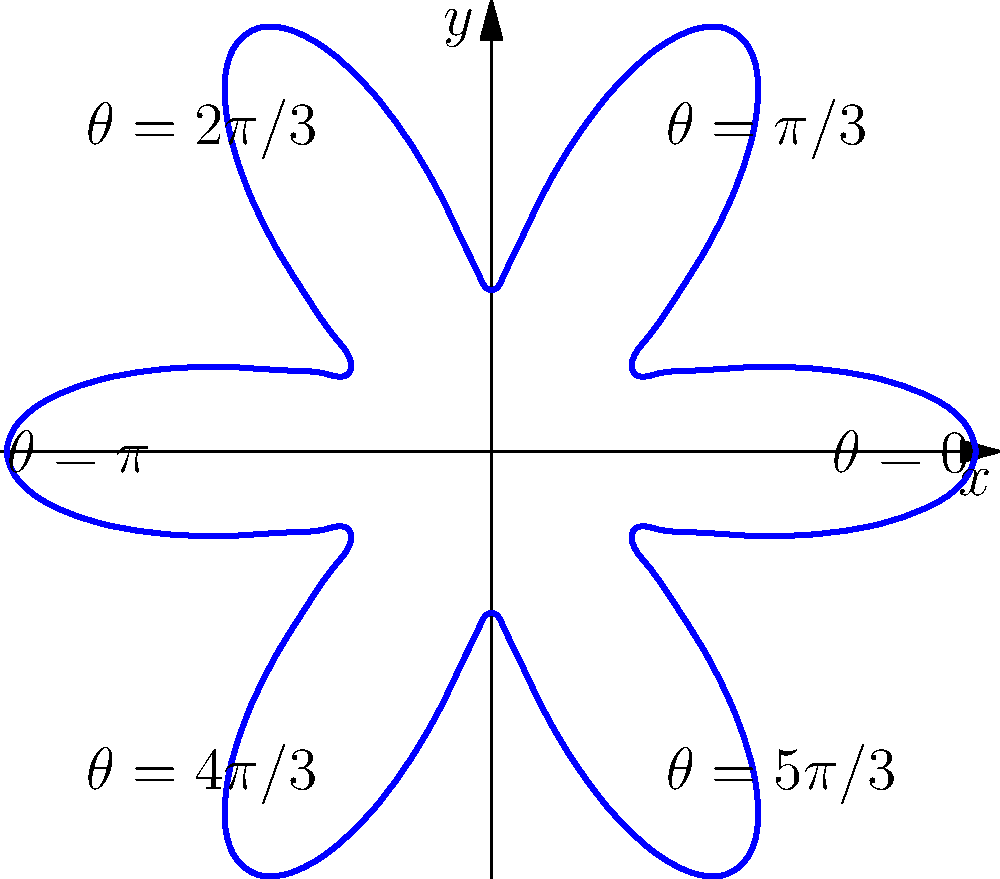In the polar coordinate representation of the electron density distribution of a benzene molecule, as shown in the figure, the radial distance $r$ is given by the function $r(\theta) = 1 + 0.5\cos(6\theta)$. At which angles $\theta$ does the electron density reach its maximum values, and what is the corresponding radial distance? To find the maximum values of the electron density, we need to follow these steps:

1) The electron density is at its maximum when $r(\theta)$ is at its maximum.

2) The function $r(\theta) = 1 + 0.5\cos(6\theta)$ reaches its maximum when $\cos(6\theta) = 1$.

3) $\cos(6\theta) = 1$ when $6\theta = 0, 2\pi, 4\pi, ...$, or more generally, when $6\theta = 2\pi n$, where $n$ is any integer.

4) Solving for $\theta$, we get $\theta = \frac{2\pi n}{6} = \frac{\pi n}{3}$, where $n = 0, 1, 2, 3, 4, 5$.

5) This gives us the angles: $0, \frac{\pi}{3}, \frac{2\pi}{3}, \pi, \frac{4\pi}{3}, \frac{5\pi}{3}$.

6) At these angles, $\cos(6\theta) = 1$, so the maximum radial distance is:
   $r_{max} = 1 + 0.5(1) = 1.5$

Therefore, the electron density reaches its maximum at angles $0, \frac{\pi}{3}, \frac{2\pi}{3}, \pi, \frac{4\pi}{3}, \frac{5\pi}{3}$, and the corresponding radial distance is 1.5.
Answer: Angles: $0, \frac{\pi}{3}, \frac{2\pi}{3}, \pi, \frac{4\pi}{3}, \frac{5\pi}{3}$; Radial distance: 1.5 